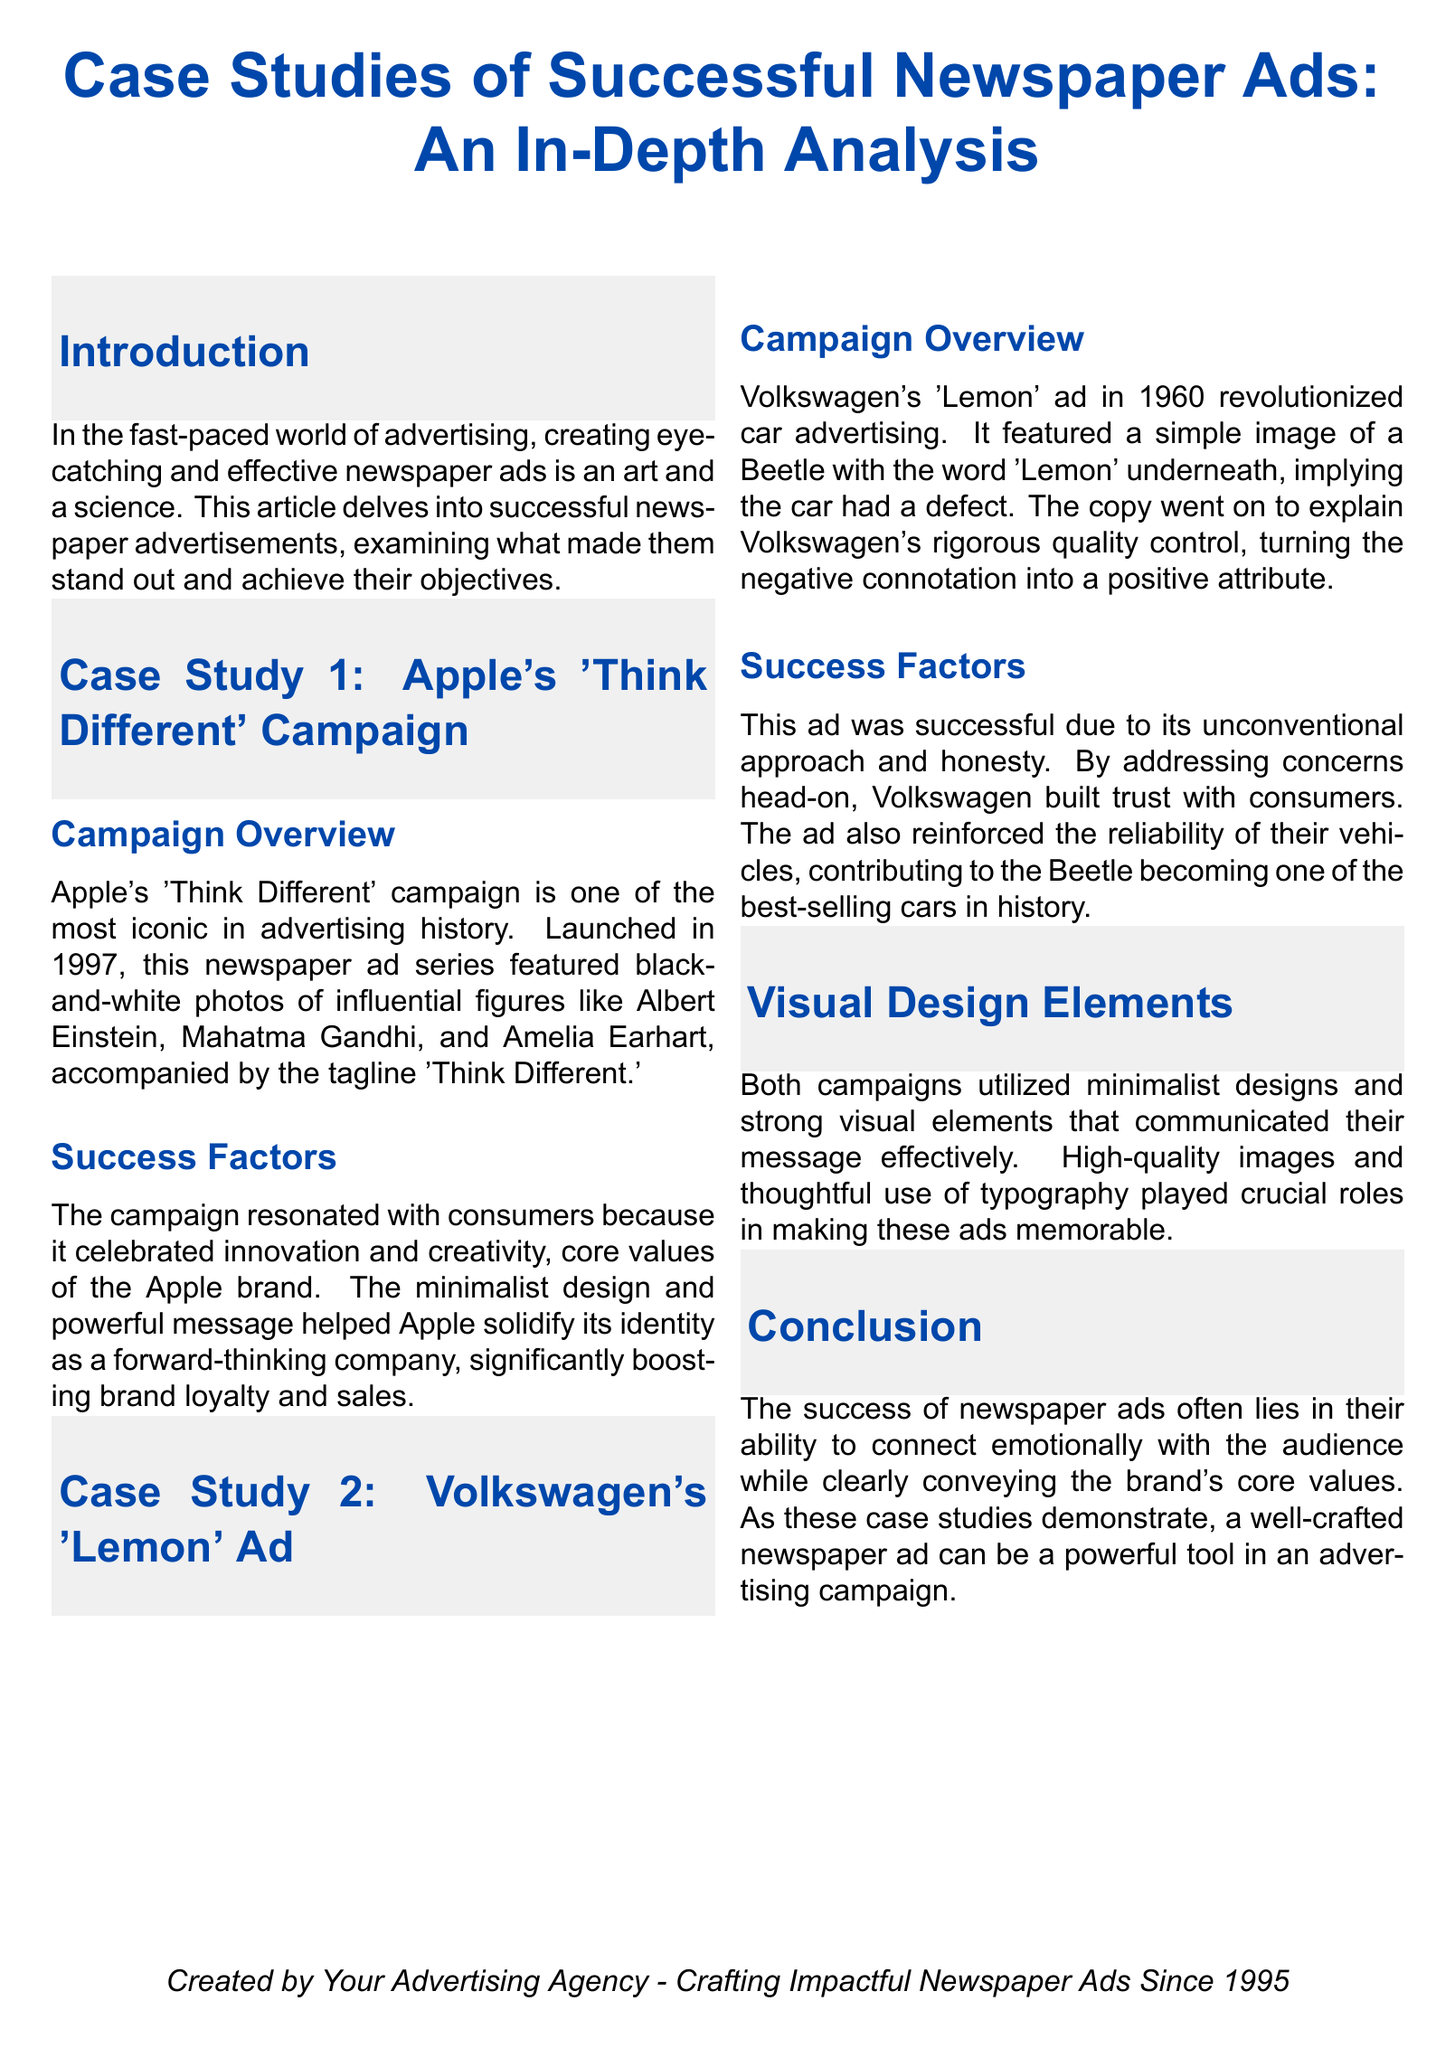what is the title of the document? The title is prominently displayed at the top of the document, highlighting the focus on case studies of successful newspaper ads.
Answer: Case Studies of Successful Newspaper Ads: An In-Depth Analysis which company launched the 'Think Different' campaign? The document specifies that this campaign is associated with a famous technology company known for its innovative products.
Answer: Apple what year was Volkswagen's 'Lemon' ad launched? The campaign overview section provides the launch year of the ad as a significant point.
Answer: 1960 what is a key visual element used in both case studies? The document mentions the design approach that was common to both Apple and Volkswagen's advertisements, emphasizing a specific aesthetic.
Answer: Minimalist design which historical figures were featured in Apple's 'Think Different' campaign? The campaign overview summarizes the influential figures that Apple associated itself with in the advertisement.
Answer: Albert Einstein, Mahatma Gandhi, and Amelia Earhart how did Volkswagen transform the meaning of the word 'Lemon'? The success factors section describes how Volkswagen addressed a negative impression in a positive manner.
Answer: Honesty what is the main theme of the document? The introduction outlines the overarching theme that connects the case studies presented, focusing on advertising and its effectiveness.
Answer: Successful newspaper advertisements what year was Your Advertising Agency established? The footer at the bottom of the document indicates the establishment year of the agency responsible for crafting the ads.
Answer: 1995 